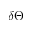<formula> <loc_0><loc_0><loc_500><loc_500>\delta \Theta</formula> 